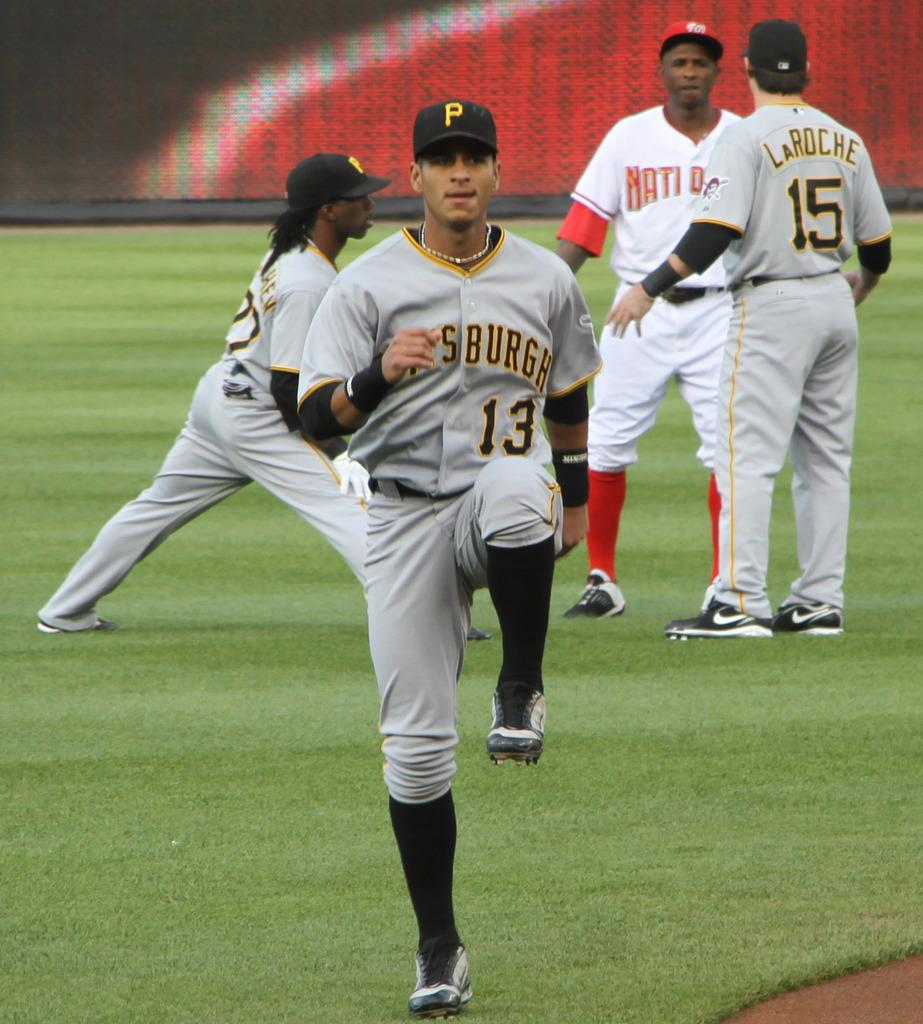<image>
Give a short and clear explanation of the subsequent image. some baseball players on the field warming up and talking, one of the teams is Pittsburgh with two of their jerseys saying numbers 15 and 13. 